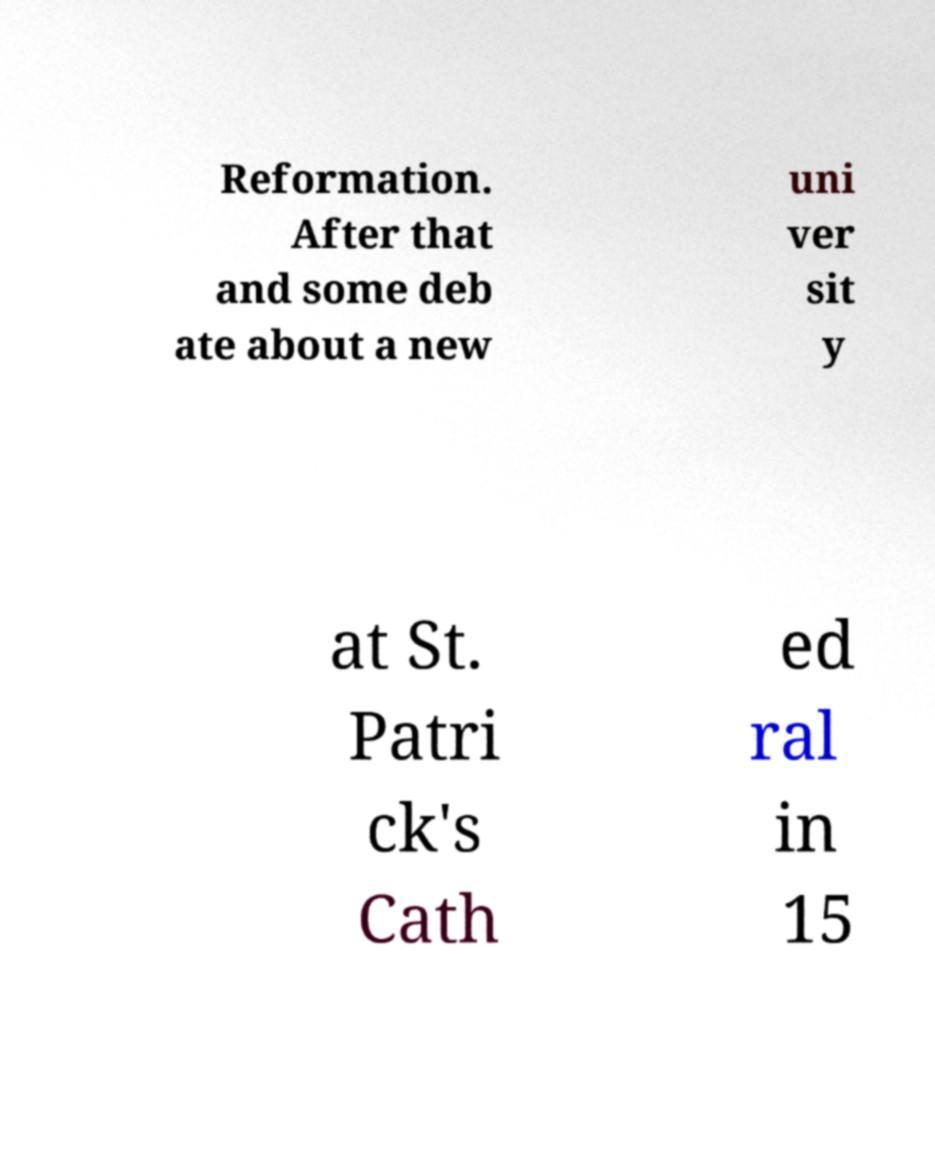Please read and relay the text visible in this image. What does it say? Reformation. After that and some deb ate about a new uni ver sit y at St. Patri ck's Cath ed ral in 15 